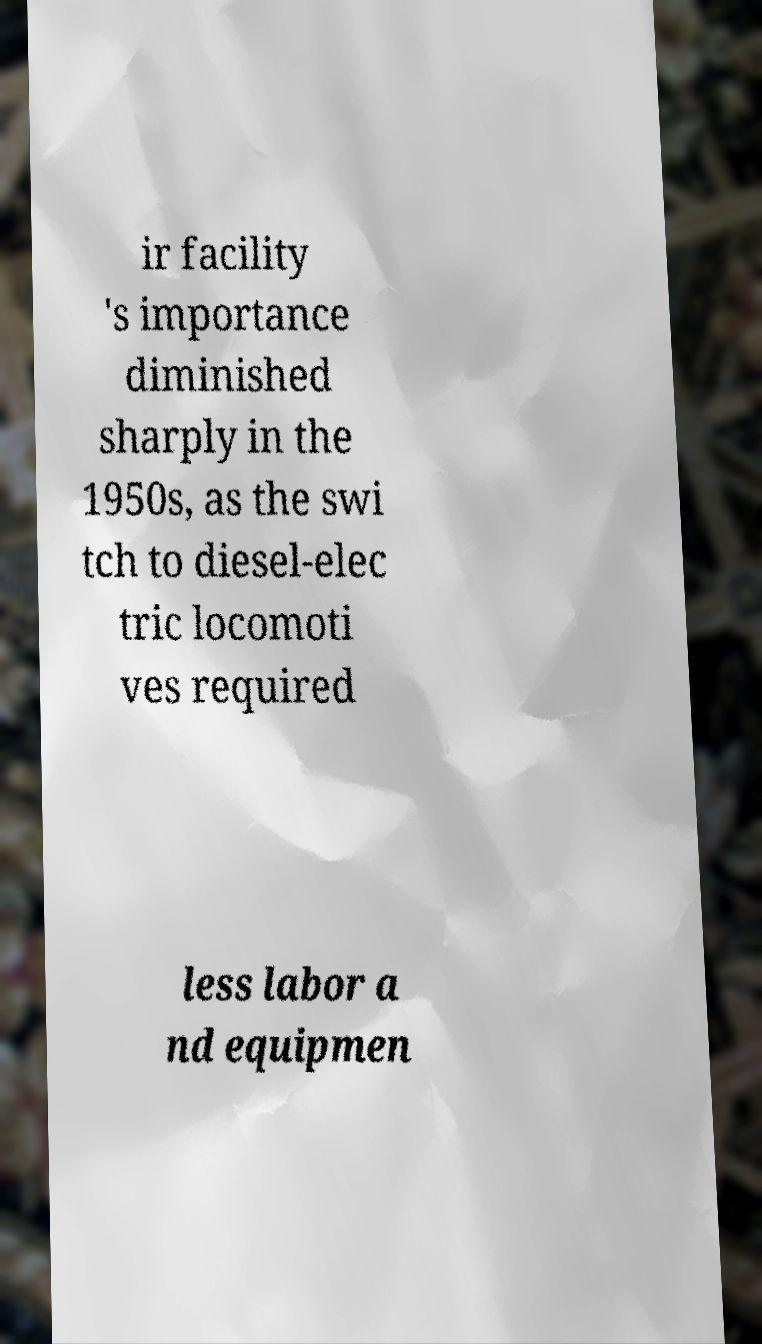Could you assist in decoding the text presented in this image and type it out clearly? ir facility 's importance diminished sharply in the 1950s, as the swi tch to diesel-elec tric locomoti ves required less labor a nd equipmen 